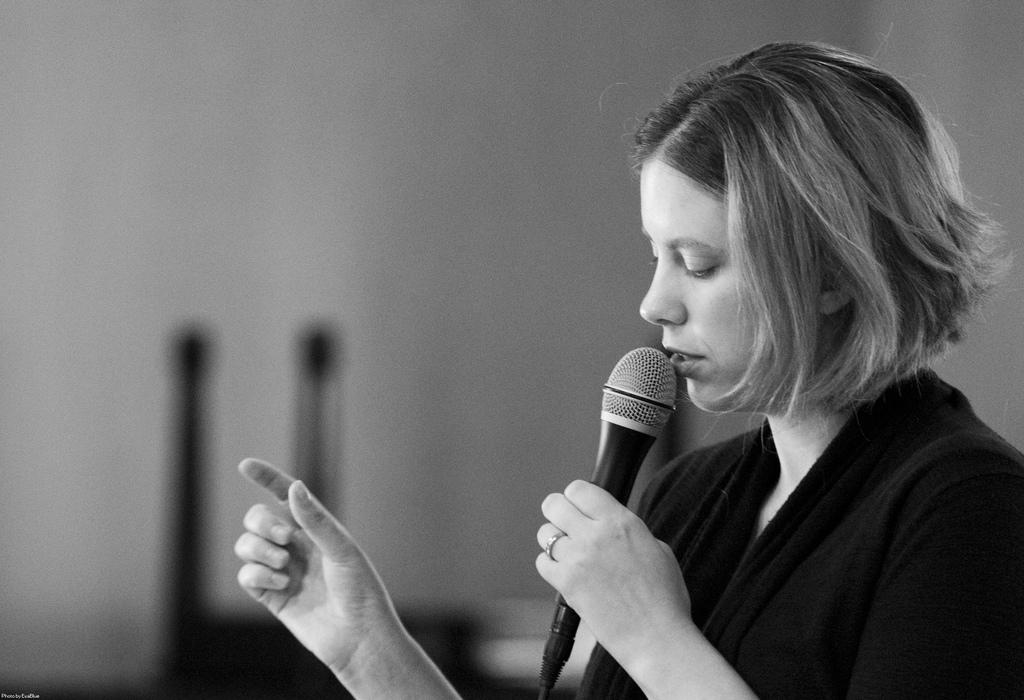What is the color scheme of the image? The image is black and white. Who is present in the image? There is a woman in the image. What is the woman holding? The woman is holding a mic. What can be seen in the background of the image? There is a wall in the background of the image. Where is the library located in the image? There is no library present in the image. Is the queen visible in the image? There is no queen present in the image; it features a woman holding a mic. 